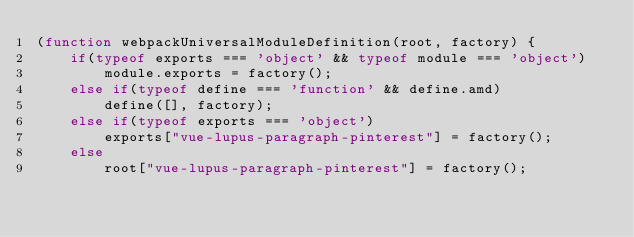<code> <loc_0><loc_0><loc_500><loc_500><_JavaScript_>(function webpackUniversalModuleDefinition(root, factory) {
	if(typeof exports === 'object' && typeof module === 'object')
		module.exports = factory();
	else if(typeof define === 'function' && define.amd)
		define([], factory);
	else if(typeof exports === 'object')
		exports["vue-lupus-paragraph-pinterest"] = factory();
	else
		root["vue-lupus-paragraph-pinterest"] = factory();</code> 